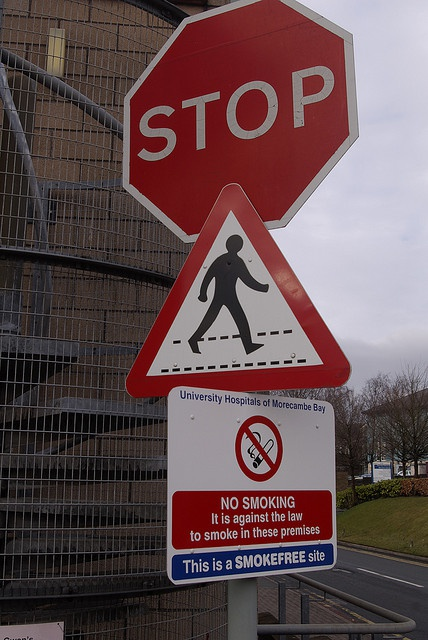Describe the objects in this image and their specific colors. I can see a stop sign in black, maroon, and gray tones in this image. 